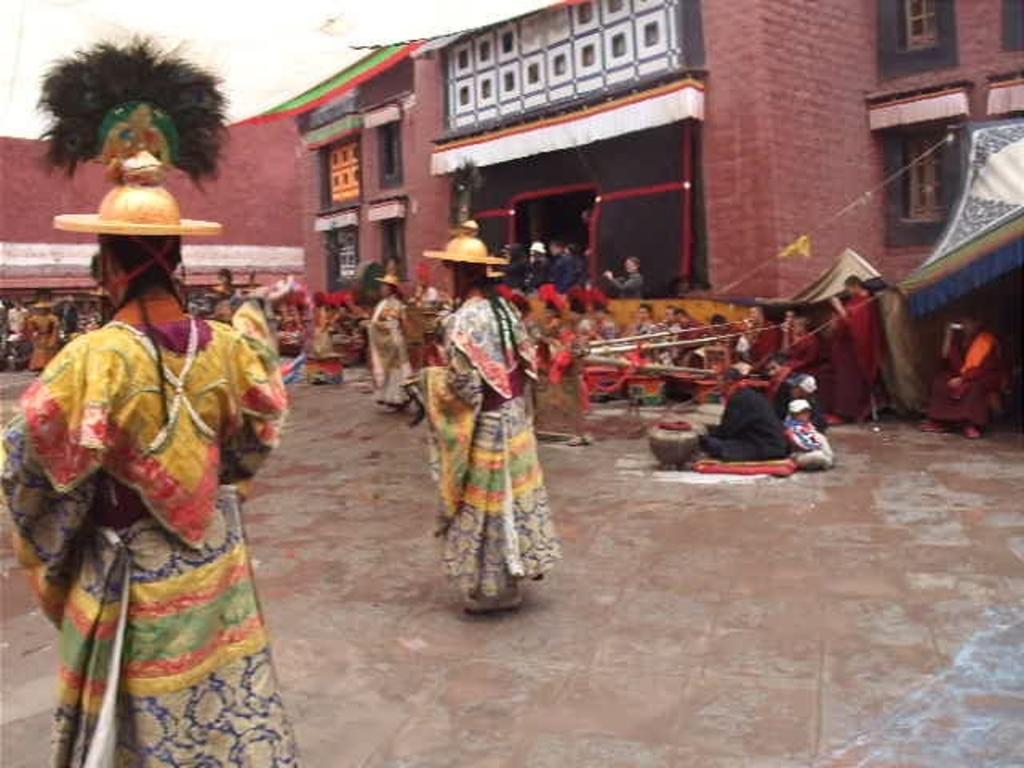What is located in the background of the image? There are persons in front of the building in the image. What can be seen on the right side of the image? There is a tent on the right side of the image. How many persons are wearing clothes and hats in the image? There are three persons wearing clothes and hats in the image. What color is the crayon being used by the person in the image? There is no crayon present in the image. Can you describe the cellar in the image? There is no cellar present in the image. 